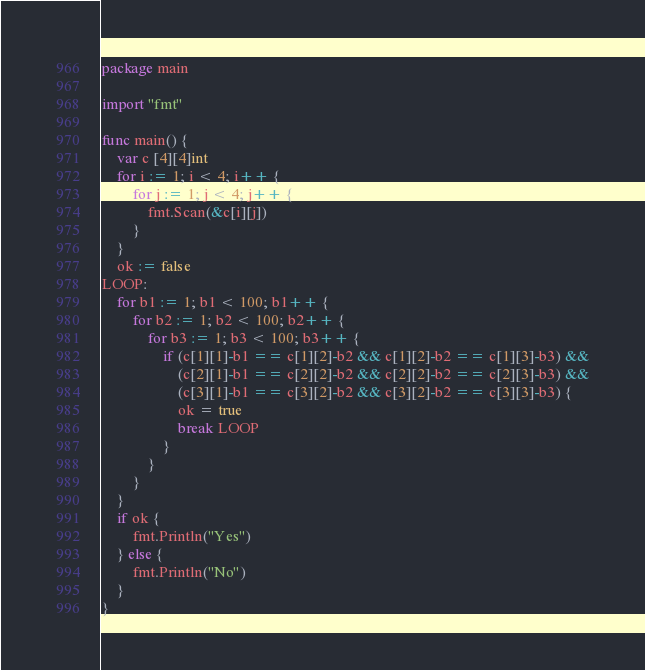<code> <loc_0><loc_0><loc_500><loc_500><_Go_>package main

import "fmt"

func main() {
	var c [4][4]int
	for i := 1; i < 4; i++ {
		for j := 1; j < 4; j++ {
			fmt.Scan(&c[i][j])
		}
	}
	ok := false
LOOP:
	for b1 := 1; b1 < 100; b1++ {
		for b2 := 1; b2 < 100; b2++ {
			for b3 := 1; b3 < 100; b3++ {
				if (c[1][1]-b1 == c[1][2]-b2 && c[1][2]-b2 == c[1][3]-b3) &&
					(c[2][1]-b1 == c[2][2]-b2 && c[2][2]-b2 == c[2][3]-b3) &&
					(c[3][1]-b1 == c[3][2]-b2 && c[3][2]-b2 == c[3][3]-b3) {
					ok = true
					break LOOP
				}
			}
		}
	}
	if ok {
		fmt.Println("Yes")
	} else {
		fmt.Println("No")
	}
}
</code> 